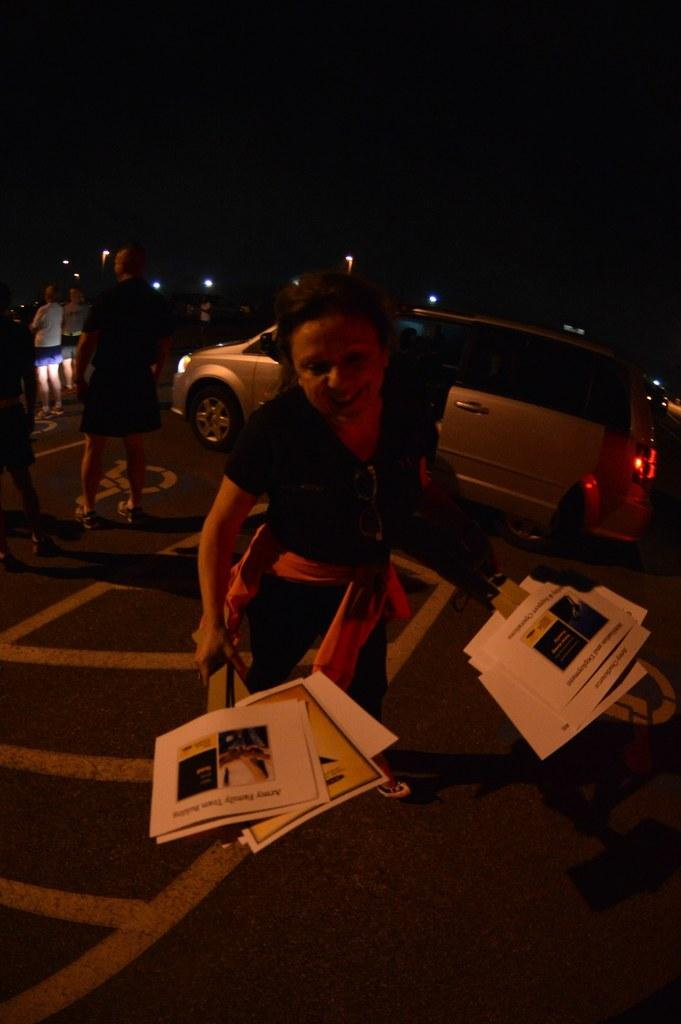Who is the main subject in the foreground of the image? There is a woman in the foreground of the image. What is the woman holding in her hand? The woman is holding posters in her hand. What can be seen in the background of the image? There are people, a vehicle, and a light in the background of the image. What type of furniture can be seen in the image? There is no furniture present in the image. How many robins are perched on the woman's shoulder in the image? There are no robins present in the image. 